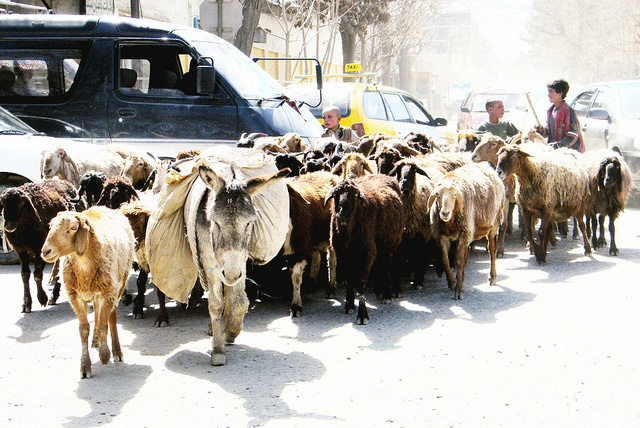Describe the objects in this image and their specific colors. I can see truck in white, black, navy, and gray tones, sheep in white, ivory, olive, and tan tones, sheep in white, black, ivory, maroon, and tan tones, sheep in white, ivory, maroon, black, and gray tones, and car in white, khaki, gray, and darkgray tones in this image. 